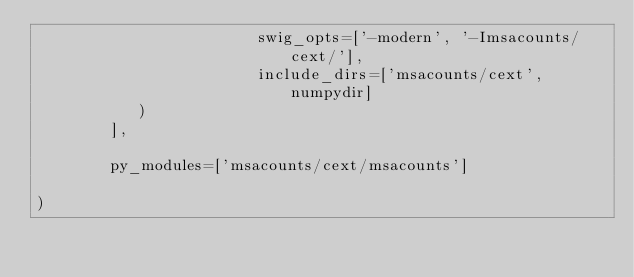<code> <loc_0><loc_0><loc_500><loc_500><_Python_>                        swig_opts=['-modern', '-Imsacounts/cext/'],
                        include_dirs=['msacounts/cext', numpydir]
           )
        ],

        py_modules=['msacounts/cext/msacounts']

)
</code> 